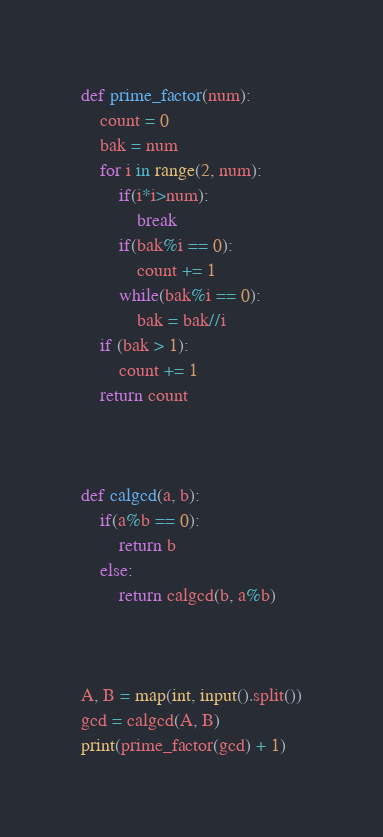Convert code to text. <code><loc_0><loc_0><loc_500><loc_500><_Python_>def prime_factor(num):
	count = 0
	bak = num
	for i in range(2, num):
		if(i*i>num):
			break
		if(bak%i == 0):
			count += 1
		while(bak%i == 0):
			bak = bak//i
	if (bak > 1):
		count += 1
	return count



def calgcd(a, b):
	if(a%b == 0):
		return b
	else:
		return calgcd(b, a%b)



A, B = map(int, input().split())
gcd = calgcd(A, B)
print(prime_factor(gcd) + 1)</code> 